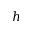<formula> <loc_0><loc_0><loc_500><loc_500>h</formula> 